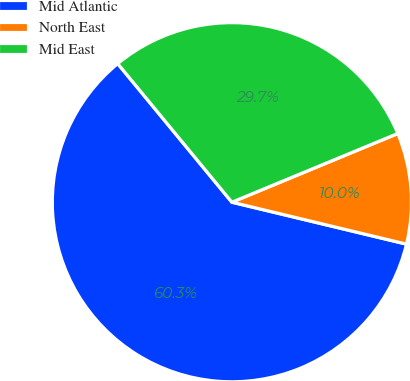Convert chart. <chart><loc_0><loc_0><loc_500><loc_500><pie_chart><fcel>Mid Atlantic<fcel>North East<fcel>Mid East<nl><fcel>60.28%<fcel>10.0%<fcel>29.72%<nl></chart> 